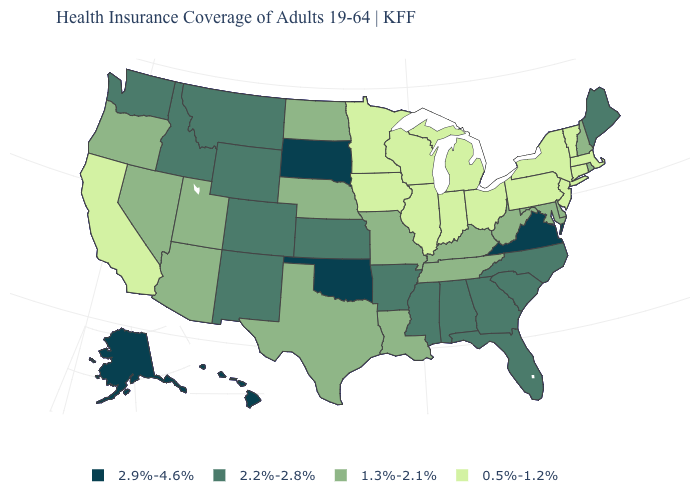Which states have the lowest value in the USA?
Give a very brief answer. California, Connecticut, Illinois, Indiana, Iowa, Massachusetts, Michigan, Minnesota, New Jersey, New York, Ohio, Pennsylvania, Vermont, Wisconsin. What is the value of Nebraska?
Keep it brief. 1.3%-2.1%. What is the value of New York?
Quick response, please. 0.5%-1.2%. Does Maine have a lower value than Arizona?
Concise answer only. No. Which states hav the highest value in the West?
Concise answer only. Alaska, Hawaii. Which states hav the highest value in the Northeast?
Be succinct. Maine. Which states have the lowest value in the USA?
Keep it brief. California, Connecticut, Illinois, Indiana, Iowa, Massachusetts, Michigan, Minnesota, New Jersey, New York, Ohio, Pennsylvania, Vermont, Wisconsin. Which states have the lowest value in the Northeast?
Write a very short answer. Connecticut, Massachusetts, New Jersey, New York, Pennsylvania, Vermont. What is the value of California?
Quick response, please. 0.5%-1.2%. What is the lowest value in the South?
Answer briefly. 1.3%-2.1%. Does the first symbol in the legend represent the smallest category?
Write a very short answer. No. Which states hav the highest value in the West?
Quick response, please. Alaska, Hawaii. Name the states that have a value in the range 2.9%-4.6%?
Write a very short answer. Alaska, Hawaii, Oklahoma, South Dakota, Virginia. Name the states that have a value in the range 2.9%-4.6%?
Keep it brief. Alaska, Hawaii, Oklahoma, South Dakota, Virginia. Name the states that have a value in the range 2.9%-4.6%?
Short answer required. Alaska, Hawaii, Oklahoma, South Dakota, Virginia. 